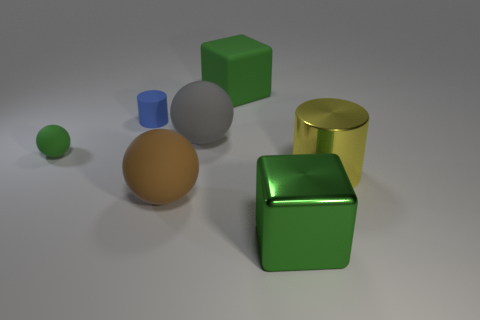If these objects were part of a child's playset, which would be safest for younger children to play with? Assuming the objects were meant to be handled by children, the green rubber sphere and the larger green cube would likely be the safest due to their lack of sharp edges and softer appearance. The rubbery texture suggests they would be less harmful if chewed or thrown. 